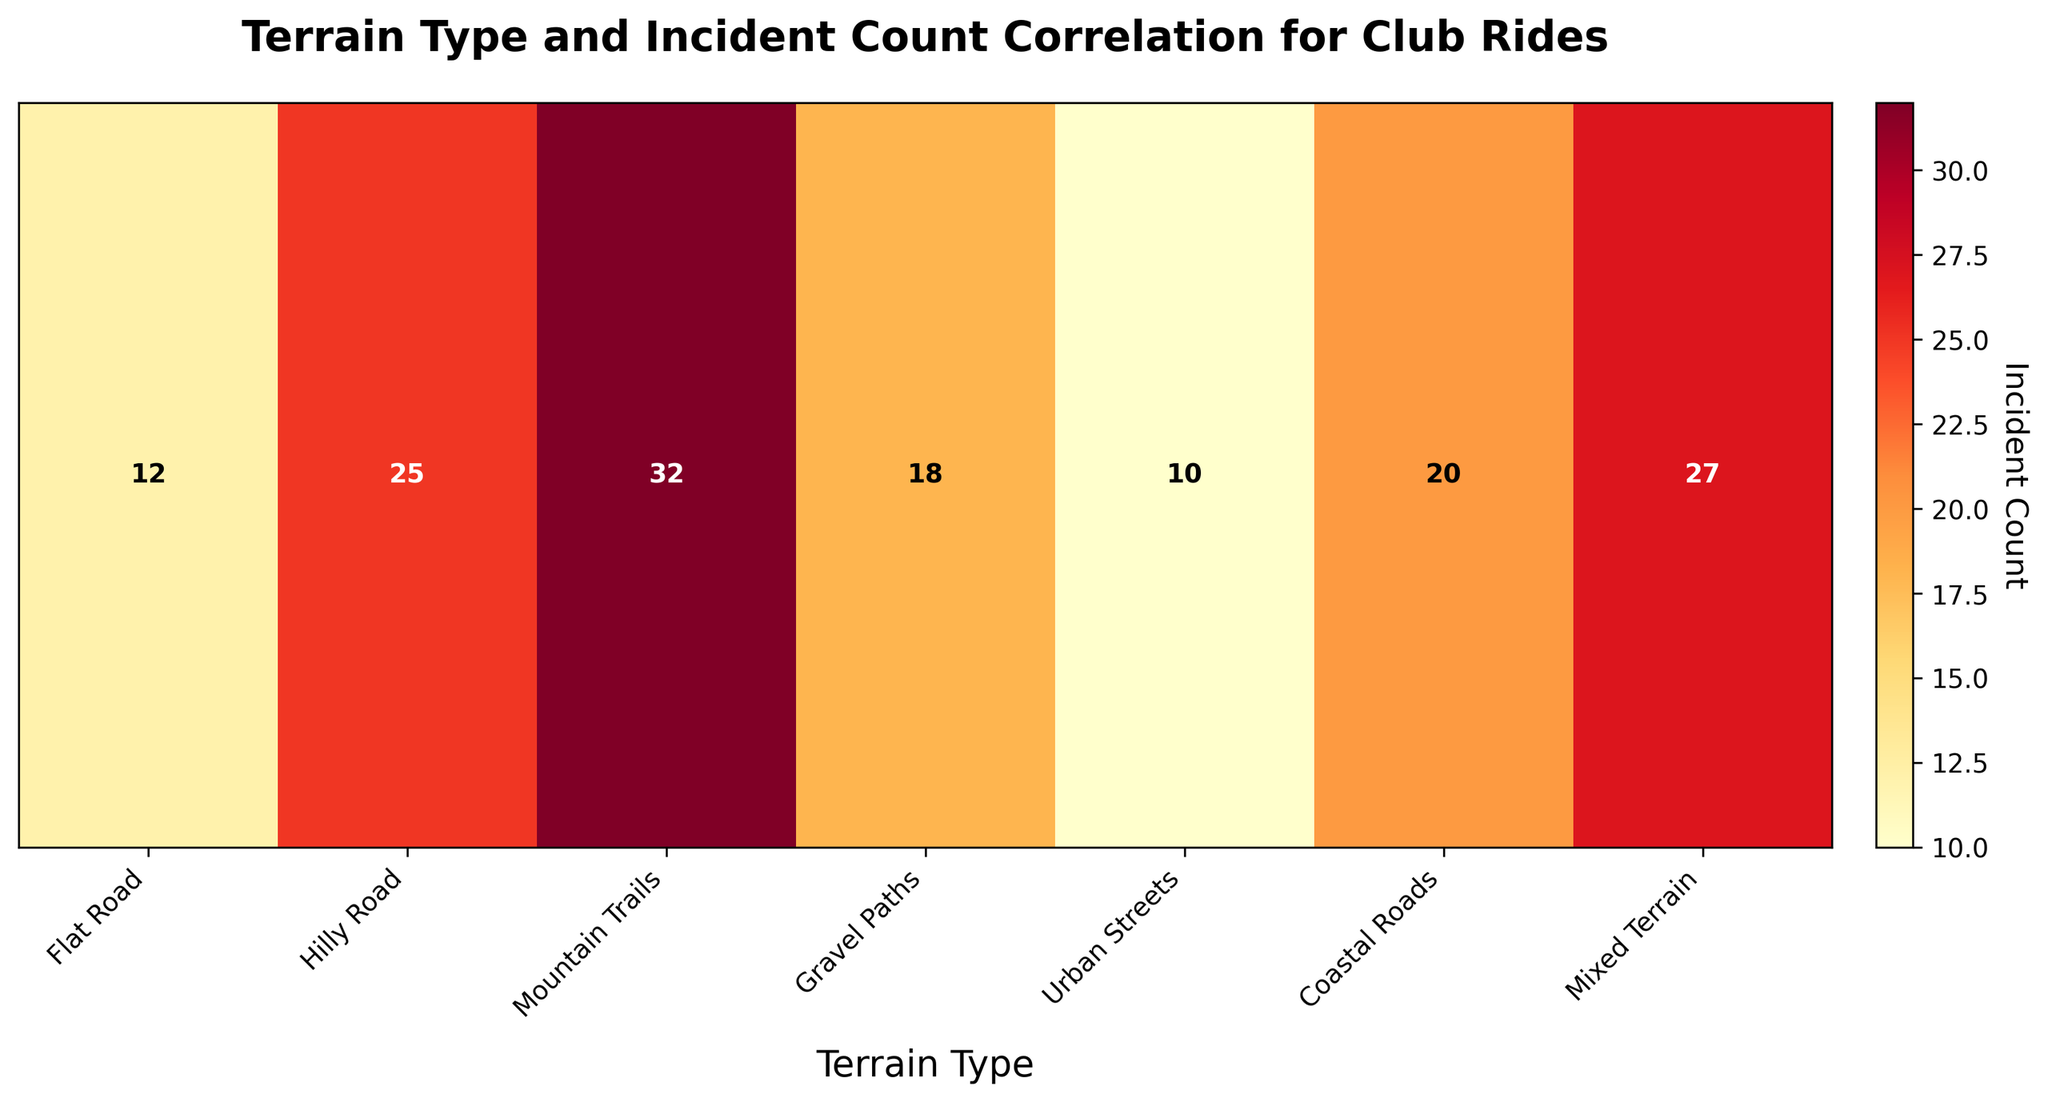What is the title of the heatmap? The title is displayed at the top of the heatmap. It reads "Terrain Type and Incident Count Correlation for Club Rides".
Answer: Terrain Type and Incident Count Correlation for Club Rides Which terrain type has the highest incident count? By observing the annotations on the heatmap, Mountain Trails has the highest incident count with a value of 32.
Answer: Mountain Trails How many terrain types have incident counts greater than 20? The heatmap shows seven terrain types with their incident counts. By checking each, four terrains (Hilly Roads, Mountain Trails, Coastal Roads, and Mixed Terrain) have incident counts greater than 20.
Answer: Four What's the difference in incident count between Mountain Trails and Urban Streets? The incident count for Mountain Trails is 32 and for Urban Streets, it is 10. The difference is 32 - 10.
Answer: 22 What color range is used to represent the incident counts? The heatmap uses a gradient from yellow to dark red, where lighter colors represent lower counts and darker colors represent higher counts.
Answer: Yellow to dark red Which terrain type has an incident count closest to 15? The heatmap shows that Gravel Paths has an incident count of 18, which is the closest to 15 among other terrain types.
Answer: Gravel Paths Compare the incident counts of Flat Road and Gravel Paths. Which one is higher? Flat Road has an incident count of 12, and Gravel Paths has 18. Thus, Gravel Paths has a higher incident count.
Answer: Gravel Paths What is the combined incident count for Flat Road and Urban Streets? The incident counts for Flat Road and Urban Streets are 12 and 10 respectively. Summing these gives 12 + 10 = 22.
Answer: 22 Which terrain type has the second highest incident count? First, identify the highest count (Mountain Trails: 32). The second highest is from Mixed Terrain with 27.
Answer: Mixed Terrain Are there more terrains with incident counts above or below 20? There are four terrain types with incident counts above 20 (Hilly Roads, Mountain Trails, Coastal Roads, Mixed Terrain) and three below 20 (Flat Road, Gravel Paths, Urban Streets).
Answer: Above 